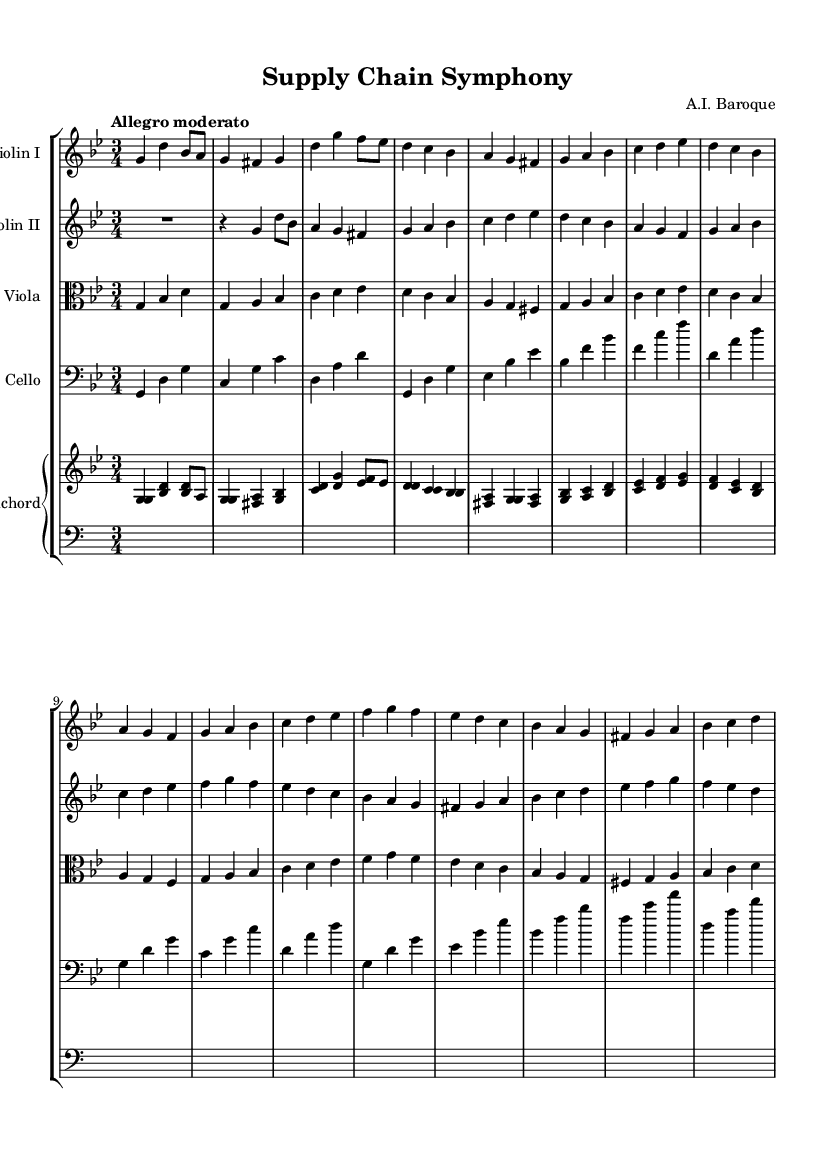What is the key signature of this music? The key signature is G minor, which has two flats (Bb and Eb) indicated on the staff.
Answer: G minor What is the time signature of this piece? The time signature is 3/4, which is noted at the beginning of the score with a '3' over a '4'. This indicates three beats per measure with the quarter note receiving one beat.
Answer: 3/4 What is the tempo marking for this piece? The tempo marking is "Allegro moderato," which suggests a moderately fast pace.
Answer: Allegro moderato How many staves are present in this score? There are five staves in total—the upper two for violins, one for viola, one for cello, and the piano staff which has two staves (upper and lower).
Answer: Five What is the purpose of the harpsichord in this chamber music? The harpsichord serves as a harmonic foundation and adds texture to the ensemble, typical of Baroque music, where it supports the other instruments.
Answer: Harmonic foundation Which instruments are featured in this chamber music composition? The instruments featured are two violins, viola, cello, and harpsichord. This combination reflects typical Baroque ensemble practice.
Answer: Two violins, viola, cello, harpsichord What is the significance of the alternating voices in the violins? The alternating voices create a dialogue effect, a common practice in Baroque music to enhance the interplay between instruments and showcase the intricacy of the composition.
Answer: Dialogue effect 